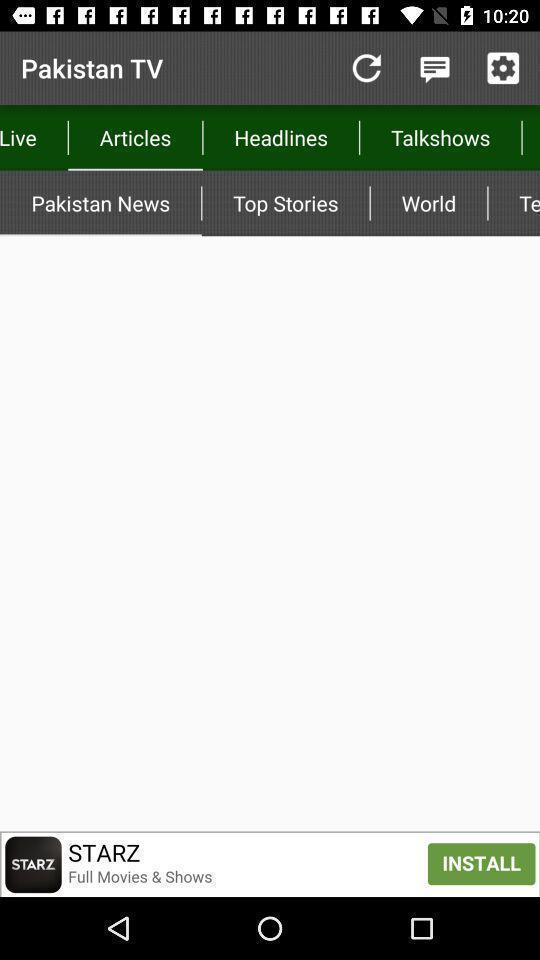Tell me what you see in this picture. Page shows the empty articles list on news app. 